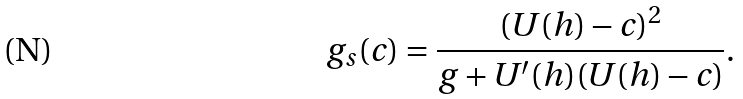Convert formula to latex. <formula><loc_0><loc_0><loc_500><loc_500>g _ { s } ( c ) = \frac { ( U ( h ) - c ) ^ { 2 } } { g + U ^ { \prime } ( h ) ( U ( h ) - c ) } .</formula> 